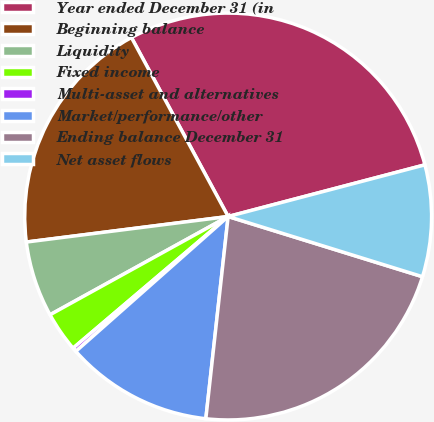Convert chart to OTSL. <chart><loc_0><loc_0><loc_500><loc_500><pie_chart><fcel>Year ended December 31 (in<fcel>Beginning balance<fcel>Liquidity<fcel>Fixed income<fcel>Multi-asset and alternatives<fcel>Market/performance/other<fcel>Ending balance December 31<fcel>Net asset flows<nl><fcel>28.8%<fcel>19.12%<fcel>6.02%<fcel>3.18%<fcel>0.33%<fcel>11.72%<fcel>21.97%<fcel>8.87%<nl></chart> 